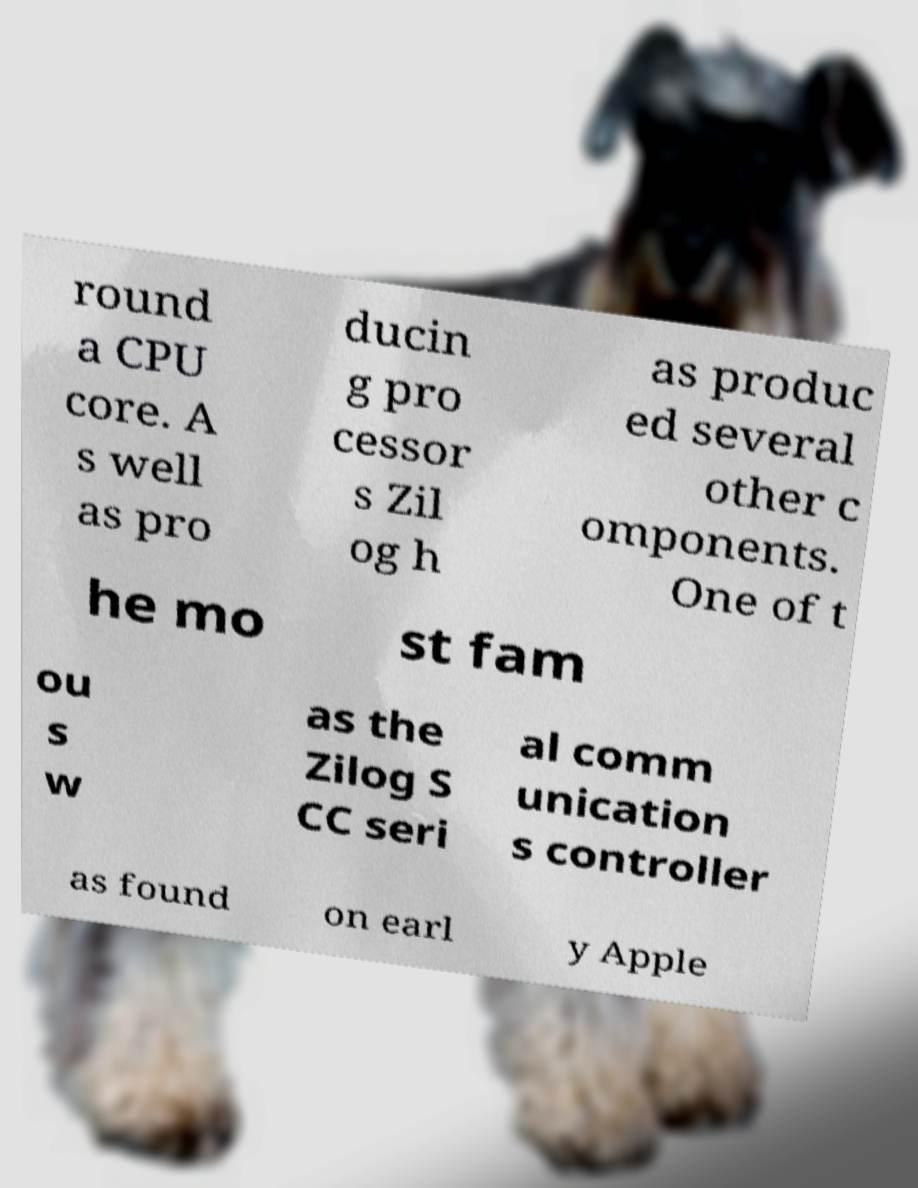For documentation purposes, I need the text within this image transcribed. Could you provide that? round a CPU core. A s well as pro ducin g pro cessor s Zil og h as produc ed several other c omponents. One of t he mo st fam ou s w as the Zilog S CC seri al comm unication s controller as found on earl y Apple 